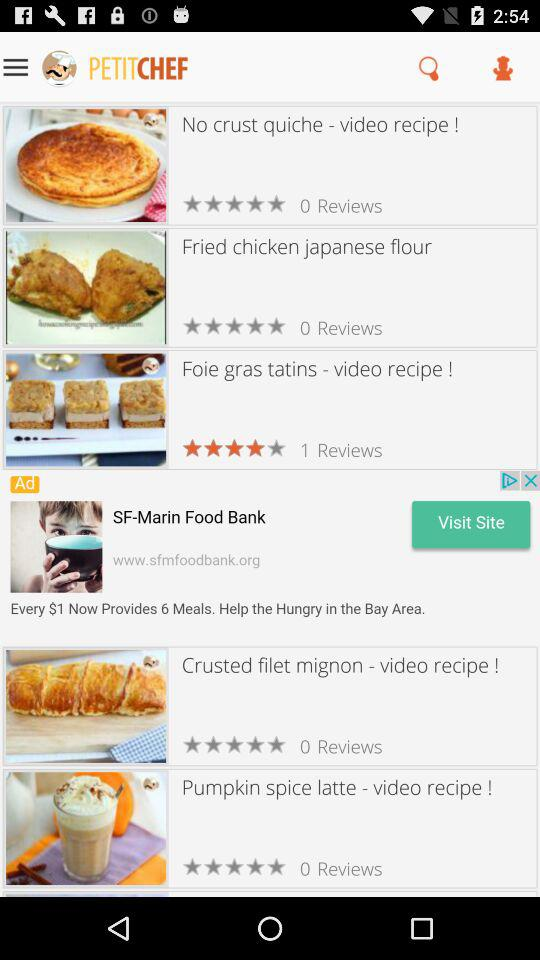How many reviews are there for the crusted filet mignon? There are zero reviews for the crusted filet mignon. 